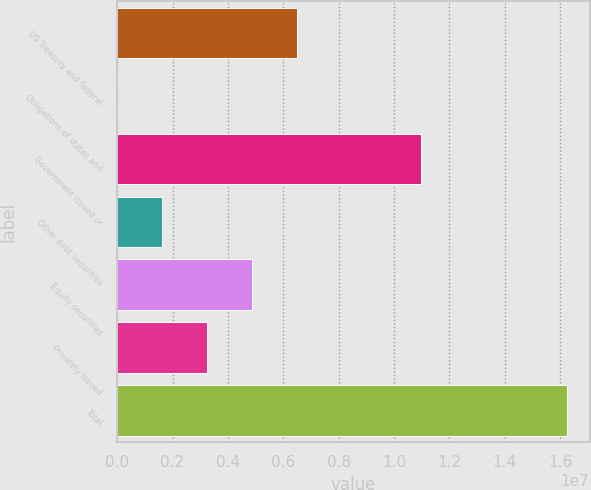<chart> <loc_0><loc_0><loc_500><loc_500><bar_chart><fcel>US Treasury and federal<fcel>Obligations of states and<fcel>Government issued or<fcel>Other debt securities<fcel>Equity securities<fcel>Privately issued<fcel>Total<nl><fcel>6.49995e+06<fcel>3641<fcel>1.09549e+07<fcel>1.62772e+06<fcel>4.87587e+06<fcel>3.2518e+06<fcel>1.62444e+07<nl></chart> 